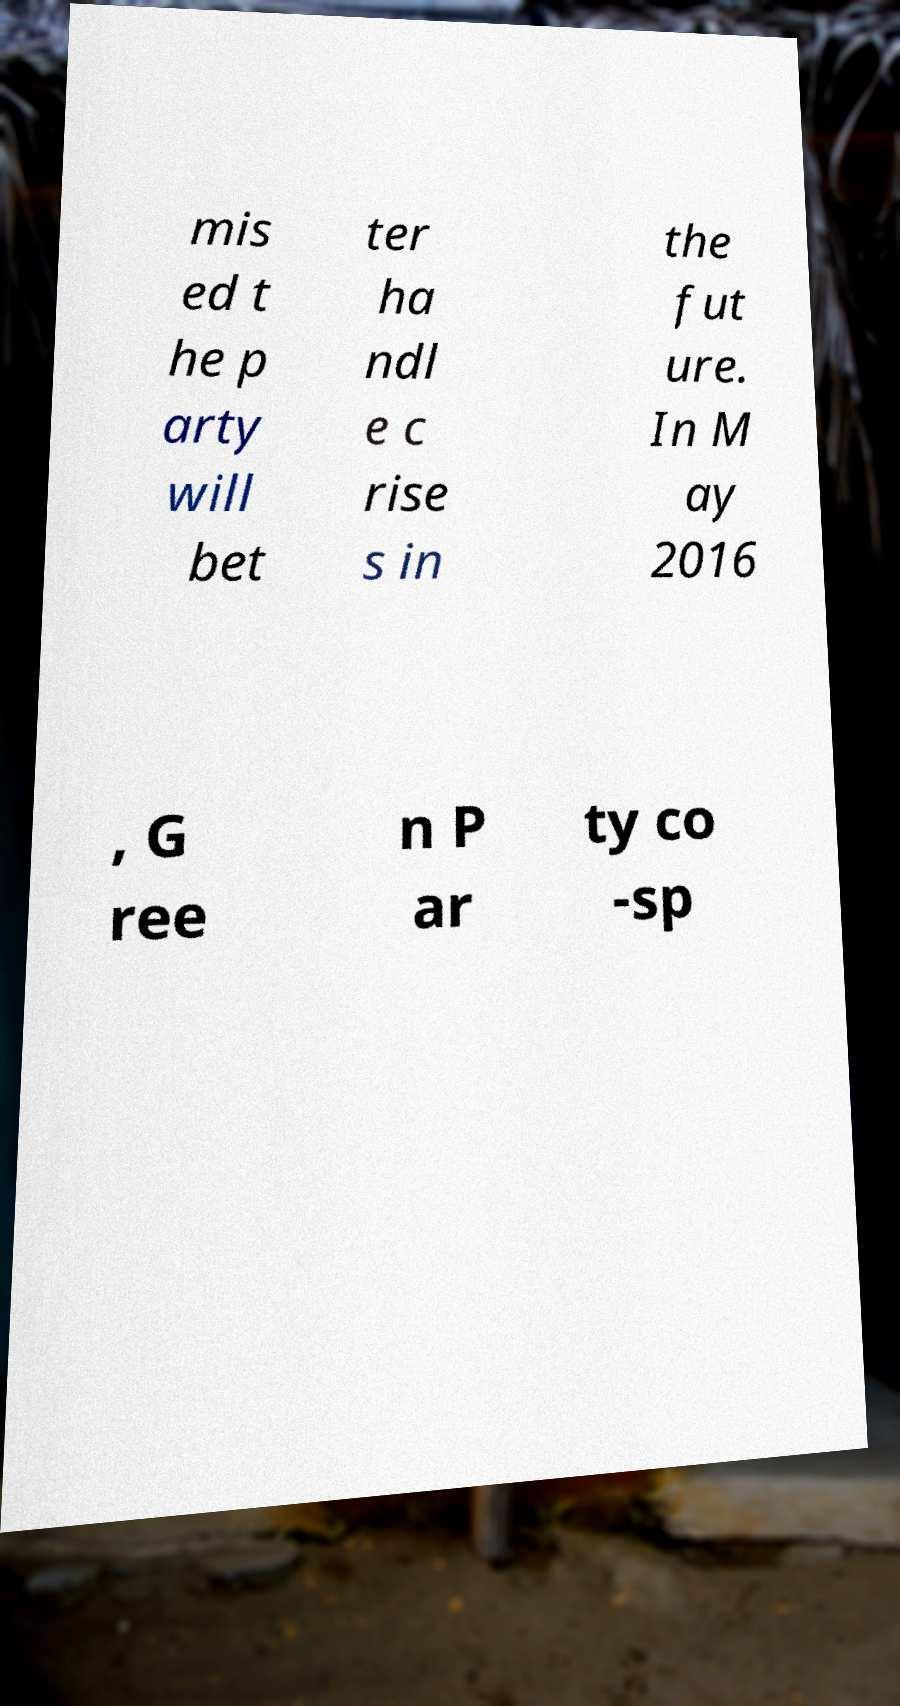Could you assist in decoding the text presented in this image and type it out clearly? mis ed t he p arty will bet ter ha ndl e c rise s in the fut ure. In M ay 2016 , G ree n P ar ty co -sp 